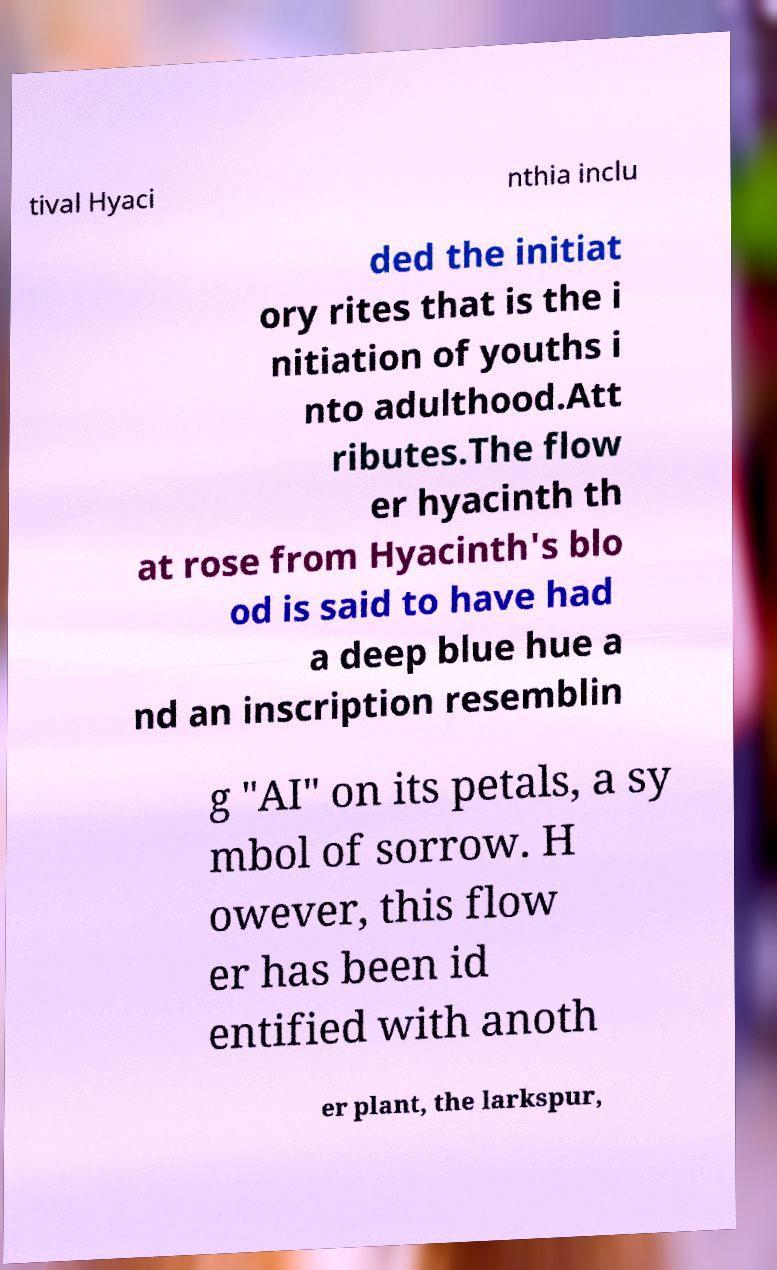Can you accurately transcribe the text from the provided image for me? tival Hyaci nthia inclu ded the initiat ory rites that is the i nitiation of youths i nto adulthood.Att ributes.The flow er hyacinth th at rose from Hyacinth's blo od is said to have had a deep blue hue a nd an inscription resemblin g "AI" on its petals, a sy mbol of sorrow. H owever, this flow er has been id entified with anoth er plant, the larkspur, 